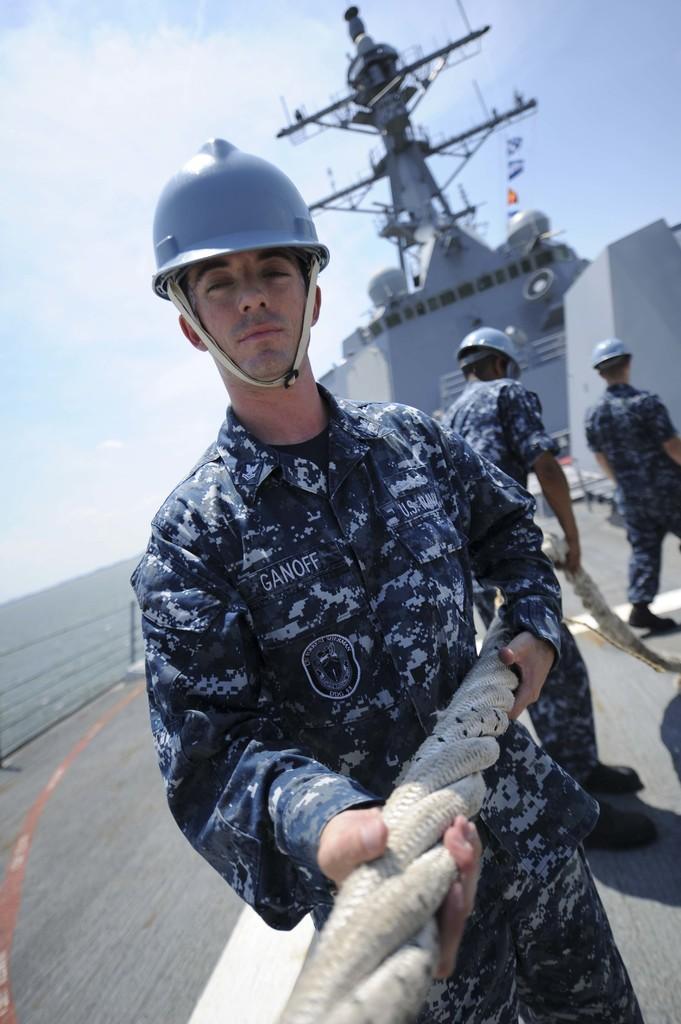Can you describe this image briefly? In the foreground of this image, there is a man wearing a helmet and holding a rope. Behind him, there is another man holding a rope and a man walking on the surface of a ship. In the background, there is water, sky and the cloud. 